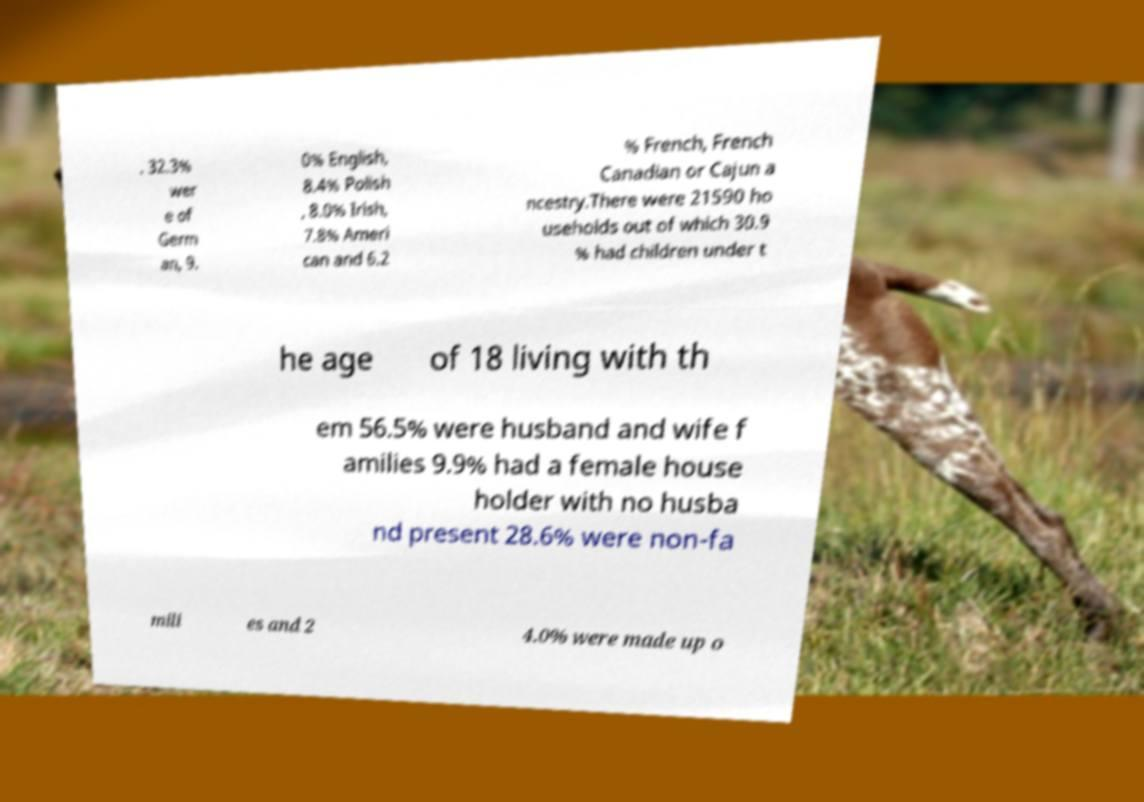Could you assist in decoding the text presented in this image and type it out clearly? . 32.3% wer e of Germ an, 9. 0% English, 8.4% Polish , 8.0% Irish, 7.8% Ameri can and 6.2 % French, French Canadian or Cajun a ncestry.There were 21590 ho useholds out of which 30.9 % had children under t he age of 18 living with th em 56.5% were husband and wife f amilies 9.9% had a female house holder with no husba nd present 28.6% were non-fa mili es and 2 4.0% were made up o 